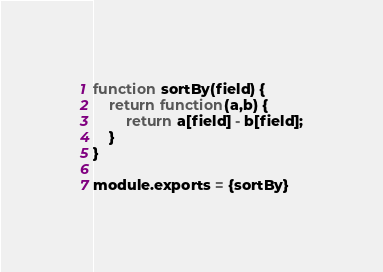<code> <loc_0><loc_0><loc_500><loc_500><_JavaScript_>function sortBy(field) {
    return function(a,b) {
        return a[field] - b[field];
    }
}

module.exports = {sortBy}</code> 